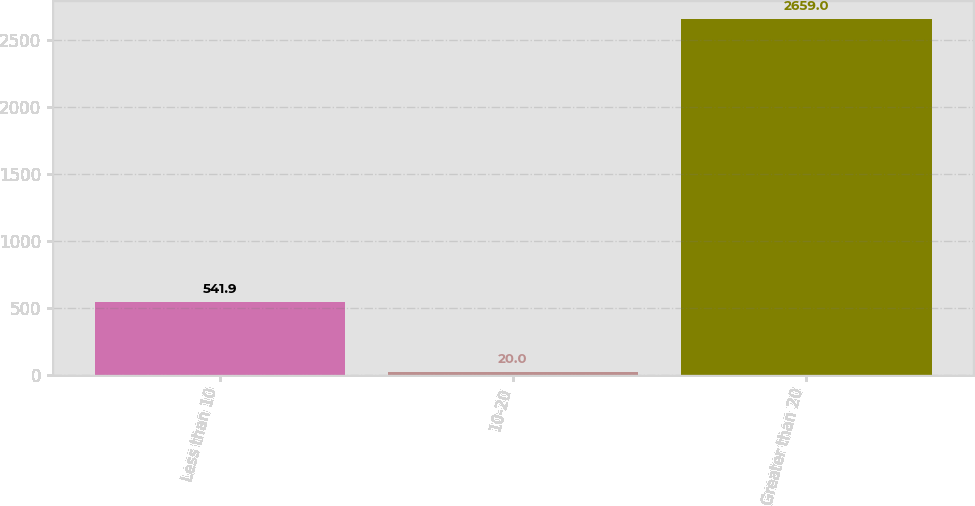Convert chart. <chart><loc_0><loc_0><loc_500><loc_500><bar_chart><fcel>Less than 10<fcel>10-20<fcel>Greater than 20<nl><fcel>541.9<fcel>20<fcel>2659<nl></chart> 